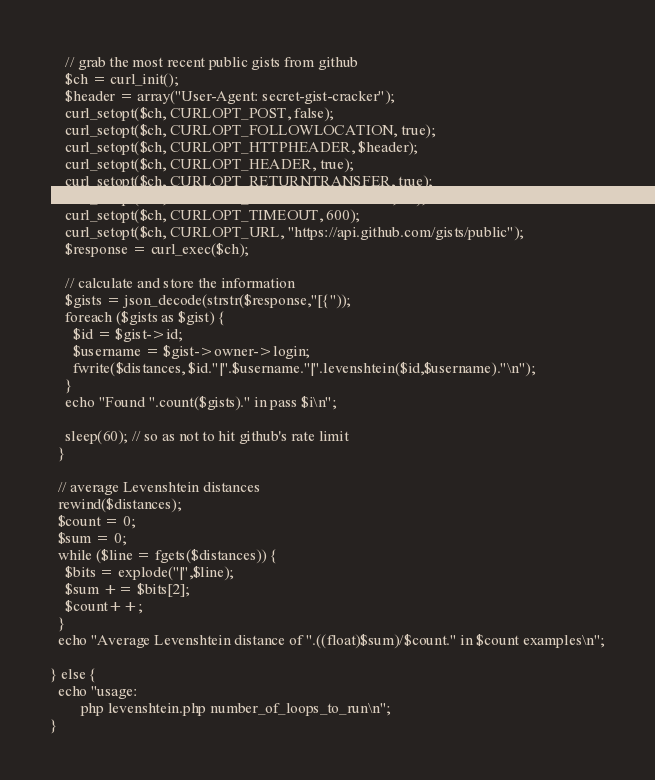<code> <loc_0><loc_0><loc_500><loc_500><_PHP_>    // grab the most recent public gists from github
    $ch = curl_init();
    $header = array("User-Agent: secret-gist-cracker");
    curl_setopt($ch, CURLOPT_POST, false);
    curl_setopt($ch, CURLOPT_FOLLOWLOCATION, true);
    curl_setopt($ch, CURLOPT_HTTPHEADER, $header);
    curl_setopt($ch, CURLOPT_HEADER, true);
    curl_setopt($ch, CURLOPT_RETURNTRANSFER, true);
    curl_setopt($ch, CURLOPT_CONNECTTIMEOUT, 30);
    curl_setopt($ch, CURLOPT_TIMEOUT, 600);
    curl_setopt($ch, CURLOPT_URL, "https://api.github.com/gists/public");
    $response = curl_exec($ch);

    // calculate and store the information
    $gists = json_decode(strstr($response,"[{"));
    foreach ($gists as $gist) {
      $id = $gist->id;
      $username = $gist->owner->login;
      fwrite($distances, $id."|".$username."|".levenshtein($id,$username)."\n");
    }
    echo "Found ".count($gists)." in pass $i\n";

    sleep(60); // so as not to hit github's rate limit
  }

  // average Levenshtein distances
  rewind($distances);
  $count = 0;
  $sum = 0;
  while ($line = fgets($distances)) {
    $bits = explode("|",$line);
    $sum += $bits[2];
    $count++;
  }
  echo "Average Levenshtein distance of ".((float)$sum)/$count." in $count examples\n";

} else {
  echo "usage:
        php levenshtein.php number_of_loops_to_run\n";
}
</code> 